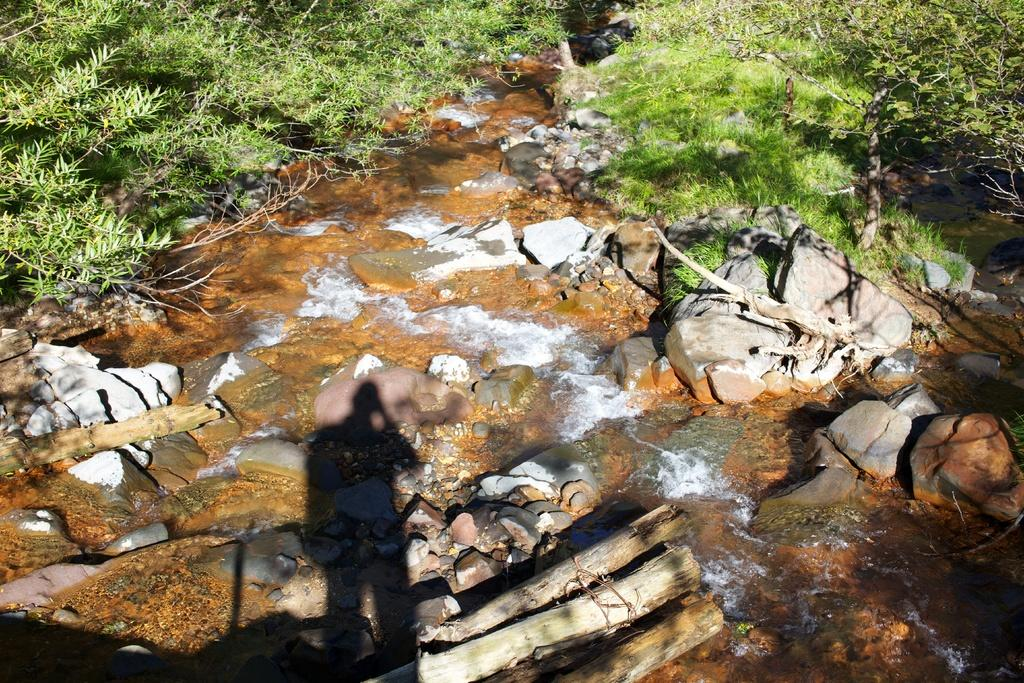What is the primary element in the image? There is flowing water in the image. What type of natural features can be seen in the image? Rocks, stones, logs, grass, and trees are visible in the image. How many types of vegetation are present in the image? There are two types of vegetation present: grass and trees. What type of fear can be seen on the face of the balloon in the image? There is no balloon present in the image, and therefore no facial expression or fear can be observed. 